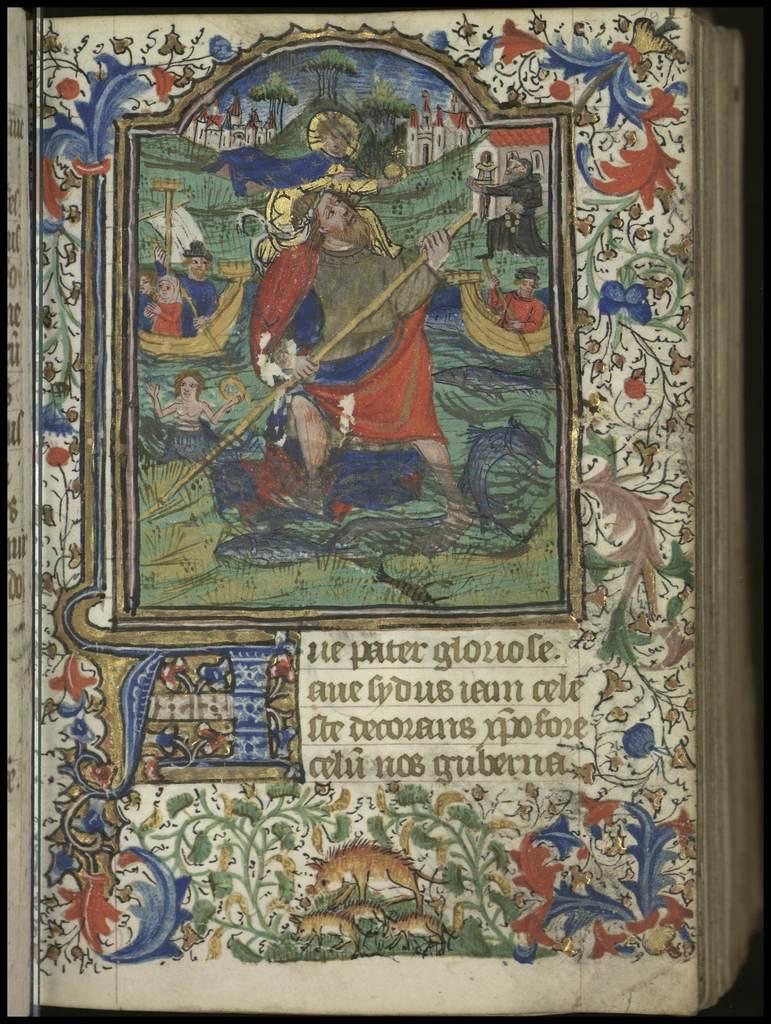Is the text on the book in english?
Give a very brief answer. No. 